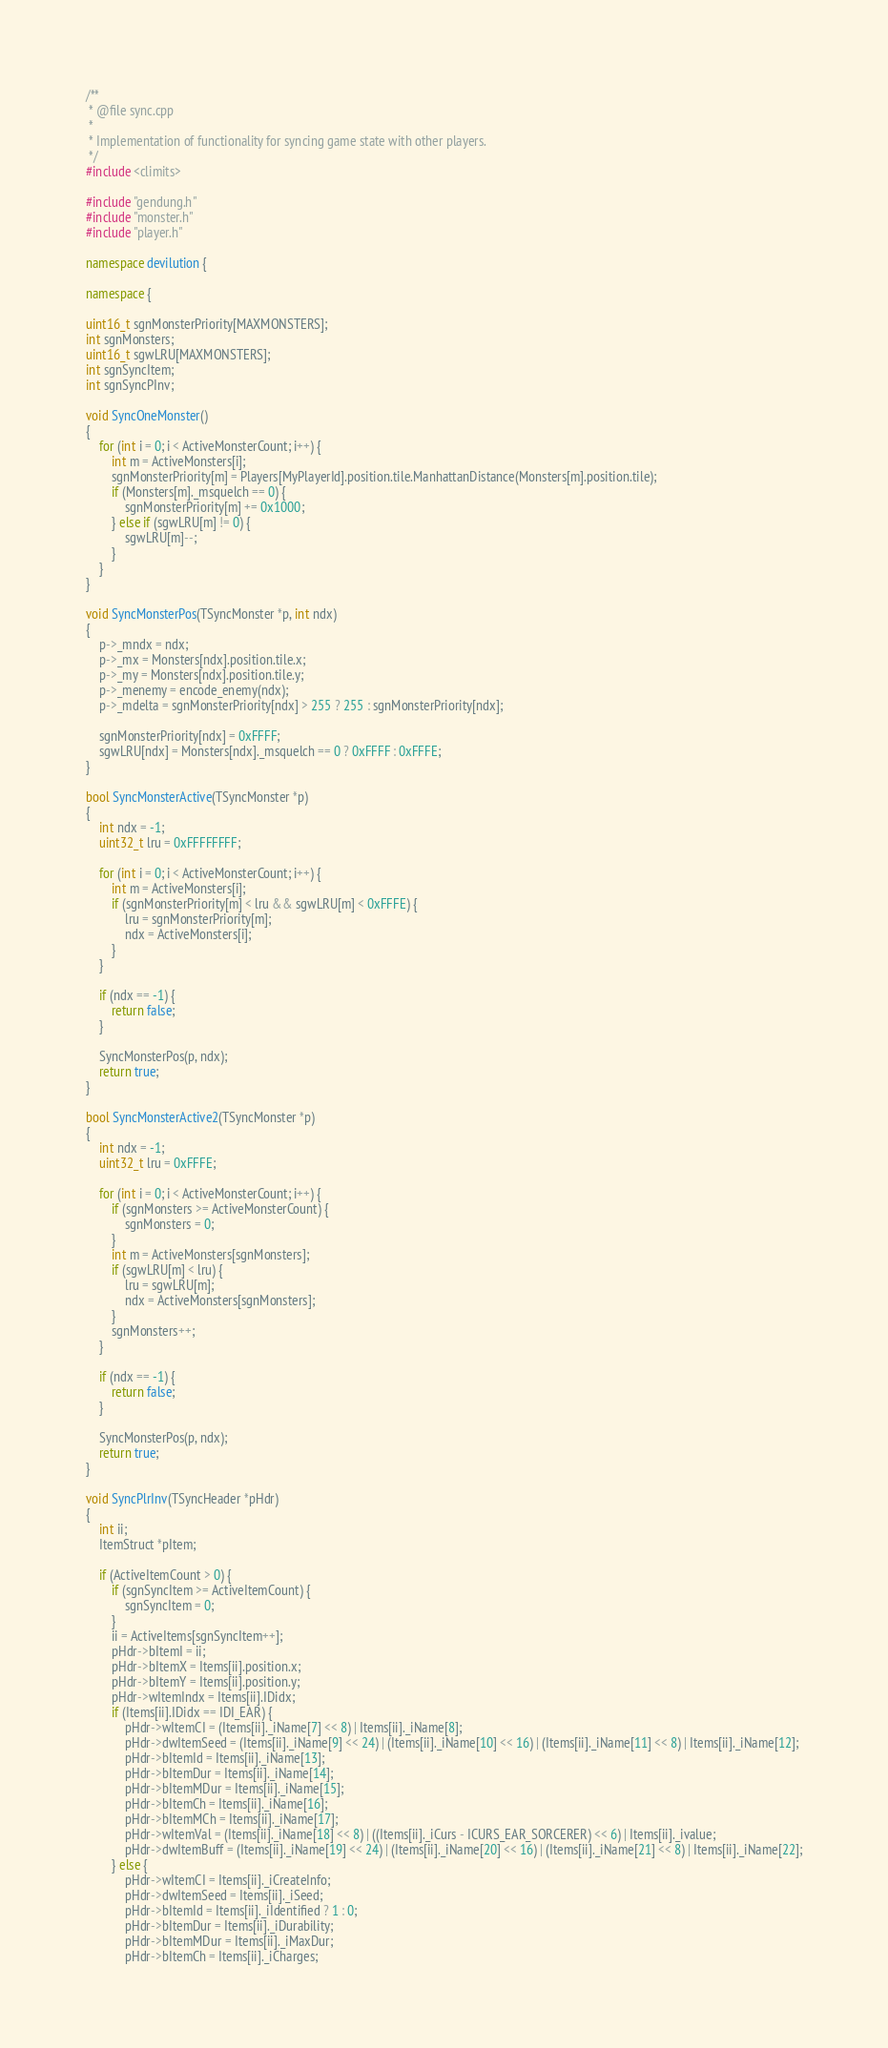Convert code to text. <code><loc_0><loc_0><loc_500><loc_500><_C++_>/**
 * @file sync.cpp
 *
 * Implementation of functionality for syncing game state with other players.
 */
#include <climits>

#include "gendung.h"
#include "monster.h"
#include "player.h"

namespace devilution {

namespace {

uint16_t sgnMonsterPriority[MAXMONSTERS];
int sgnMonsters;
uint16_t sgwLRU[MAXMONSTERS];
int sgnSyncItem;
int sgnSyncPInv;

void SyncOneMonster()
{
	for (int i = 0; i < ActiveMonsterCount; i++) {
		int m = ActiveMonsters[i];
		sgnMonsterPriority[m] = Players[MyPlayerId].position.tile.ManhattanDistance(Monsters[m].position.tile);
		if (Monsters[m]._msquelch == 0) {
			sgnMonsterPriority[m] += 0x1000;
		} else if (sgwLRU[m] != 0) {
			sgwLRU[m]--;
		}
	}
}

void SyncMonsterPos(TSyncMonster *p, int ndx)
{
	p->_mndx = ndx;
	p->_mx = Monsters[ndx].position.tile.x;
	p->_my = Monsters[ndx].position.tile.y;
	p->_menemy = encode_enemy(ndx);
	p->_mdelta = sgnMonsterPriority[ndx] > 255 ? 255 : sgnMonsterPriority[ndx];

	sgnMonsterPriority[ndx] = 0xFFFF;
	sgwLRU[ndx] = Monsters[ndx]._msquelch == 0 ? 0xFFFF : 0xFFFE;
}

bool SyncMonsterActive(TSyncMonster *p)
{
	int ndx = -1;
	uint32_t lru = 0xFFFFFFFF;

	for (int i = 0; i < ActiveMonsterCount; i++) {
		int m = ActiveMonsters[i];
		if (sgnMonsterPriority[m] < lru && sgwLRU[m] < 0xFFFE) {
			lru = sgnMonsterPriority[m];
			ndx = ActiveMonsters[i];
		}
	}

	if (ndx == -1) {
		return false;
	}

	SyncMonsterPos(p, ndx);
	return true;
}

bool SyncMonsterActive2(TSyncMonster *p)
{
	int ndx = -1;
	uint32_t lru = 0xFFFE;

	for (int i = 0; i < ActiveMonsterCount; i++) {
		if (sgnMonsters >= ActiveMonsterCount) {
			sgnMonsters = 0;
		}
		int m = ActiveMonsters[sgnMonsters];
		if (sgwLRU[m] < lru) {
			lru = sgwLRU[m];
			ndx = ActiveMonsters[sgnMonsters];
		}
		sgnMonsters++;
	}

	if (ndx == -1) {
		return false;
	}

	SyncMonsterPos(p, ndx);
	return true;
}

void SyncPlrInv(TSyncHeader *pHdr)
{
	int ii;
	ItemStruct *pItem;

	if (ActiveItemCount > 0) {
		if (sgnSyncItem >= ActiveItemCount) {
			sgnSyncItem = 0;
		}
		ii = ActiveItems[sgnSyncItem++];
		pHdr->bItemI = ii;
		pHdr->bItemX = Items[ii].position.x;
		pHdr->bItemY = Items[ii].position.y;
		pHdr->wItemIndx = Items[ii].IDidx;
		if (Items[ii].IDidx == IDI_EAR) {
			pHdr->wItemCI = (Items[ii]._iName[7] << 8) | Items[ii]._iName[8];
			pHdr->dwItemSeed = (Items[ii]._iName[9] << 24) | (Items[ii]._iName[10] << 16) | (Items[ii]._iName[11] << 8) | Items[ii]._iName[12];
			pHdr->bItemId = Items[ii]._iName[13];
			pHdr->bItemDur = Items[ii]._iName[14];
			pHdr->bItemMDur = Items[ii]._iName[15];
			pHdr->bItemCh = Items[ii]._iName[16];
			pHdr->bItemMCh = Items[ii]._iName[17];
			pHdr->wItemVal = (Items[ii]._iName[18] << 8) | ((Items[ii]._iCurs - ICURS_EAR_SORCERER) << 6) | Items[ii]._ivalue;
			pHdr->dwItemBuff = (Items[ii]._iName[19] << 24) | (Items[ii]._iName[20] << 16) | (Items[ii]._iName[21] << 8) | Items[ii]._iName[22];
		} else {
			pHdr->wItemCI = Items[ii]._iCreateInfo;
			pHdr->dwItemSeed = Items[ii]._iSeed;
			pHdr->bItemId = Items[ii]._iIdentified ? 1 : 0;
			pHdr->bItemDur = Items[ii]._iDurability;
			pHdr->bItemMDur = Items[ii]._iMaxDur;
			pHdr->bItemCh = Items[ii]._iCharges;</code> 